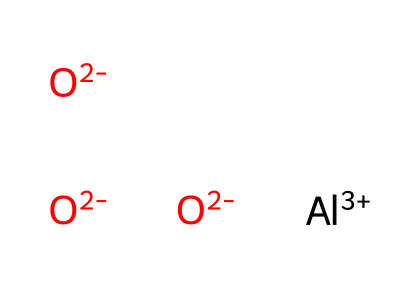What is the molecular formula of the chemical represented by the SMILES? The SMILES representation shows three oxygen atoms and one aluminum atom, indicating the molecular formula is AlO3.
Answer: AlO3 How many aluminum atoms are present in this chemical structure? By examining the SMILES, we see there is one aluminum atom denoted by [Al+3].
Answer: one How many oxygen atoms are represented in the structure? The SMILES shows three oxygen atoms, represented by three instances of [O-2].
Answer: three What charge does the aluminum atom have in this chemical? The SMILES shows the aluminum atom with a notation of +3, indicating it has a +3 charge.
Answer: +3 What is the primary use of aluminum oxide ceramics in joint replacements? Aluminum oxide ceramics are primarily used for their wear resistance and biocompatibility in joint replacements.
Answer: wear resistance How does the ionic charge of aluminum affect its bonding with oxygen? The positive charge of aluminum (+3) creates a strong ionic bond with the negatively charged oxygen atoms (-2), allowing for stable bonding.
Answer: strong ionic bond What type of material does this chemical represent in terms of its structure? The arrangement of aluminum and oxygen atoms in this way indicates that this chemical represents a ceramic material.
Answer: ceramic material 